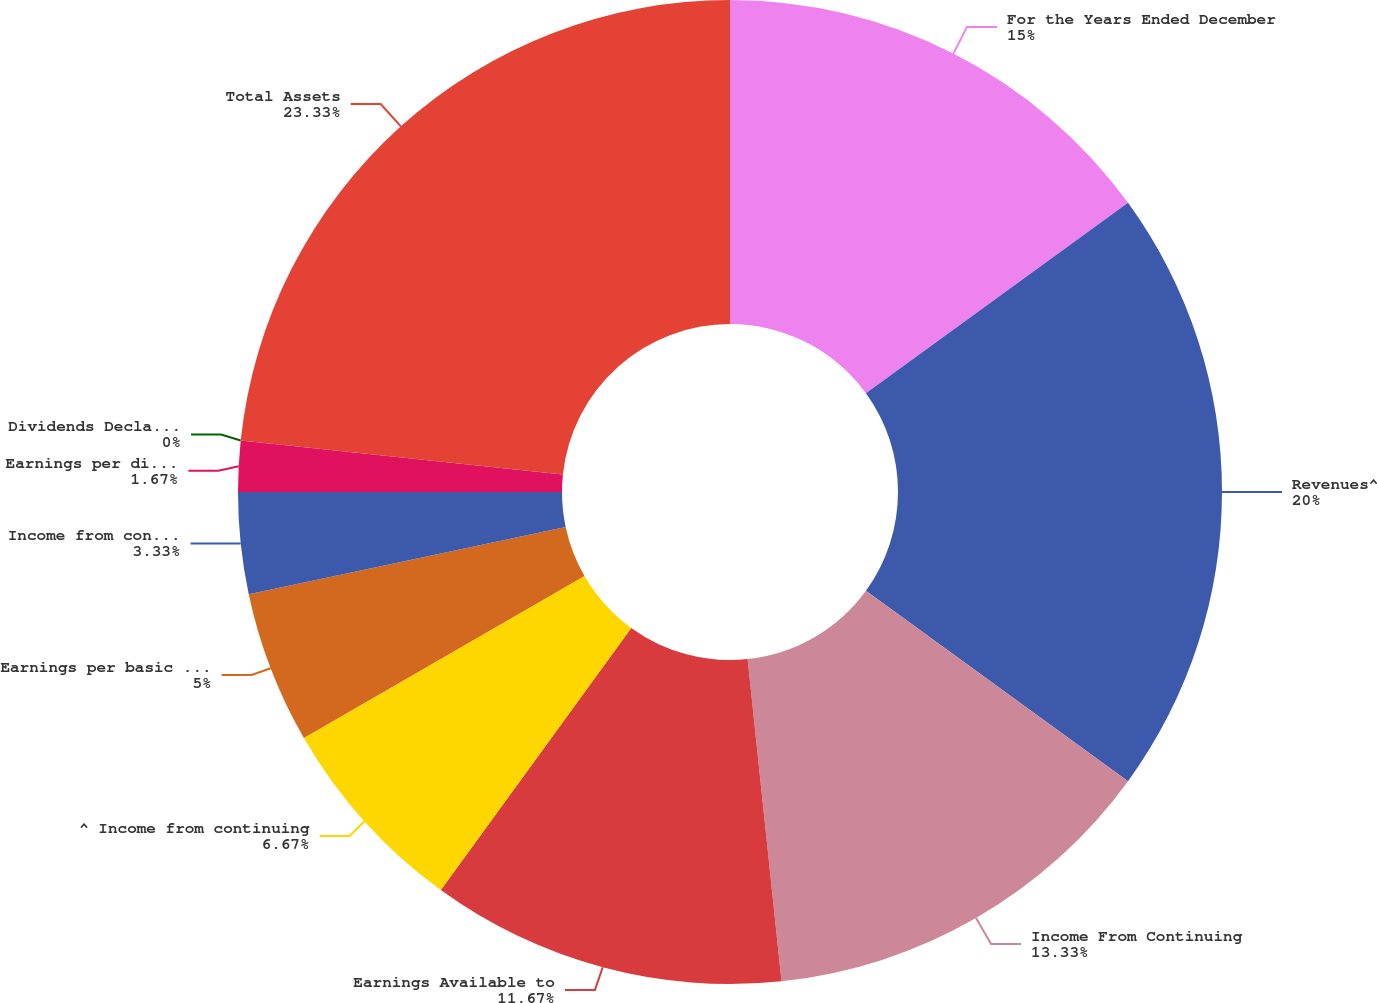Convert chart. <chart><loc_0><loc_0><loc_500><loc_500><pie_chart><fcel>For the Years Ended December<fcel>Revenues^<fcel>Income From Continuing<fcel>Earnings Available to<fcel>^ Income from continuing<fcel>Earnings per basic share<fcel>Income from continuing<fcel>Earnings per diluted share<fcel>Dividends Declared per Share<fcel>Total Assets<nl><fcel>15.0%<fcel>20.0%<fcel>13.33%<fcel>11.67%<fcel>6.67%<fcel>5.0%<fcel>3.33%<fcel>1.67%<fcel>0.0%<fcel>23.33%<nl></chart> 